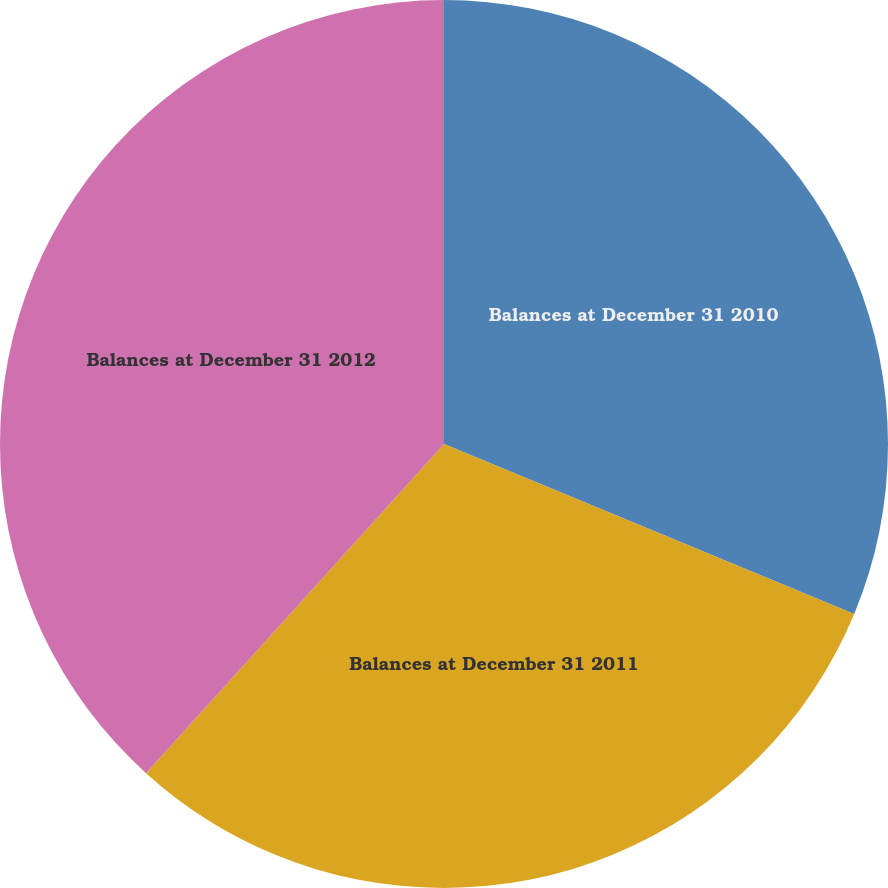Convert chart. <chart><loc_0><loc_0><loc_500><loc_500><pie_chart><fcel>Balances at December 31 2010<fcel>Balances at December 31 2011<fcel>Balances at December 31 2012<nl><fcel>31.25%<fcel>30.46%<fcel>38.29%<nl></chart> 